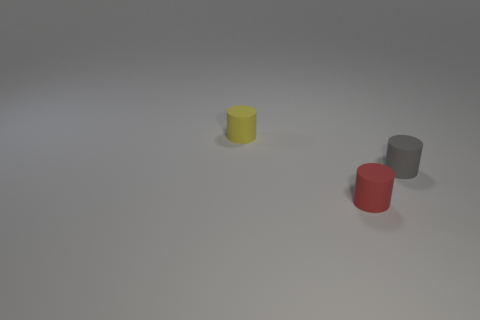Subtract all small gray rubber cylinders. How many cylinders are left? 2 Add 3 small cyan matte blocks. How many objects exist? 6 Subtract all red cylinders. How many cylinders are left? 2 Subtract all big yellow cylinders. Subtract all tiny red matte cylinders. How many objects are left? 2 Add 3 yellow cylinders. How many yellow cylinders are left? 4 Add 2 tiny gray rubber cylinders. How many tiny gray rubber cylinders exist? 3 Subtract 0 cyan balls. How many objects are left? 3 Subtract 1 cylinders. How many cylinders are left? 2 Subtract all yellow cylinders. Subtract all purple cubes. How many cylinders are left? 2 Subtract all purple balls. How many gray cylinders are left? 1 